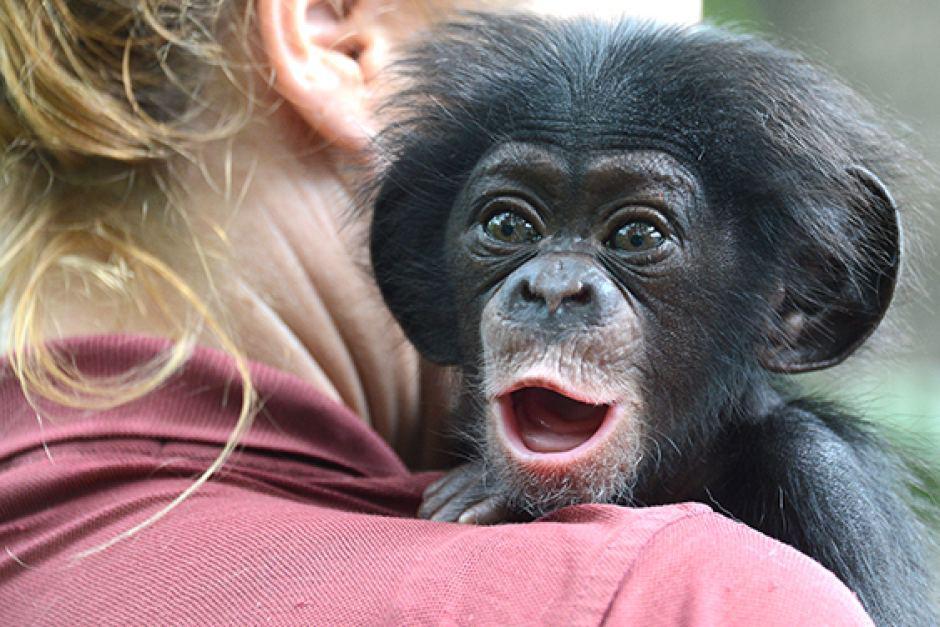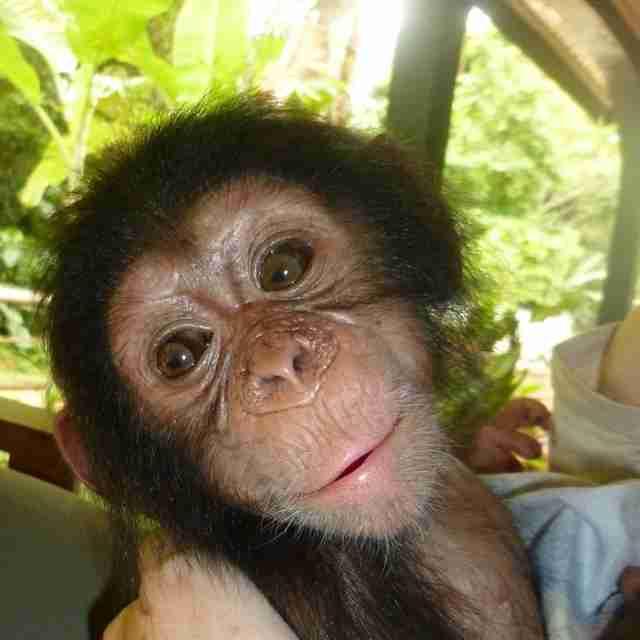The first image is the image on the left, the second image is the image on the right. For the images shown, is this caption "A mother and a baby ape is pictured on the right image." true? Answer yes or no. No. 